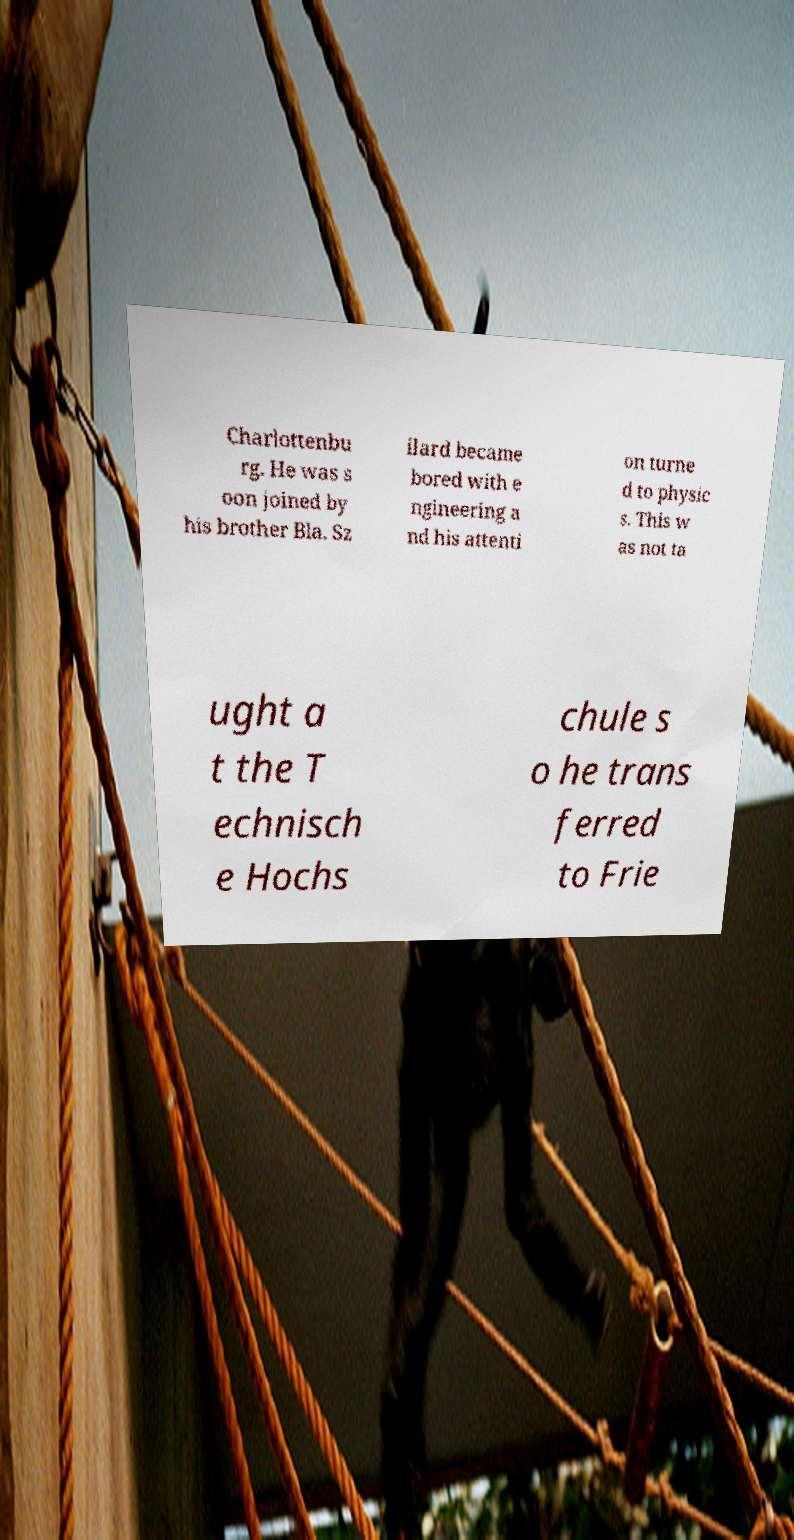Can you accurately transcribe the text from the provided image for me? Charlottenbu rg. He was s oon joined by his brother Bla. Sz ilard became bored with e ngineering a nd his attenti on turne d to physic s. This w as not ta ught a t the T echnisch e Hochs chule s o he trans ferred to Frie 